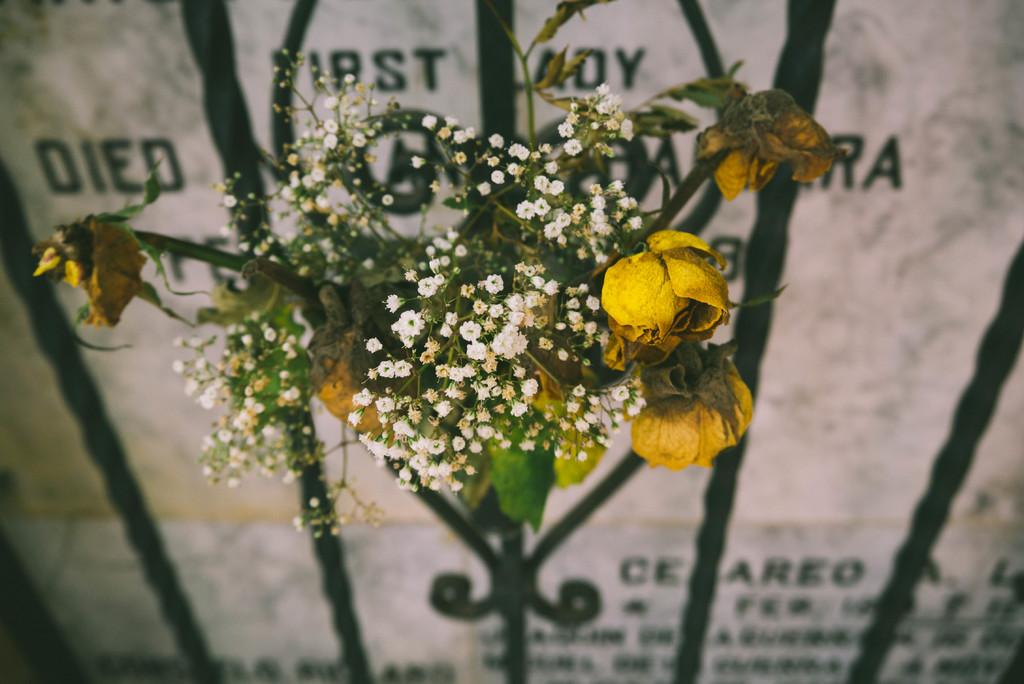What can be seen in the image that represents a collection of flowers? There is a flower bouquet in the image. What type of structure is present in the image that is associated with burial or commemoration? There is a gravestone in the image. What information is provided on the gravestone? There is writing on the gravestone. What type of zipper can be seen on the gravestone in the image? There is no zipper present on the gravestone in the image. What class is being held at the location of the gravestone in the image? There is no class being held at the location of the gravestone in the image. 